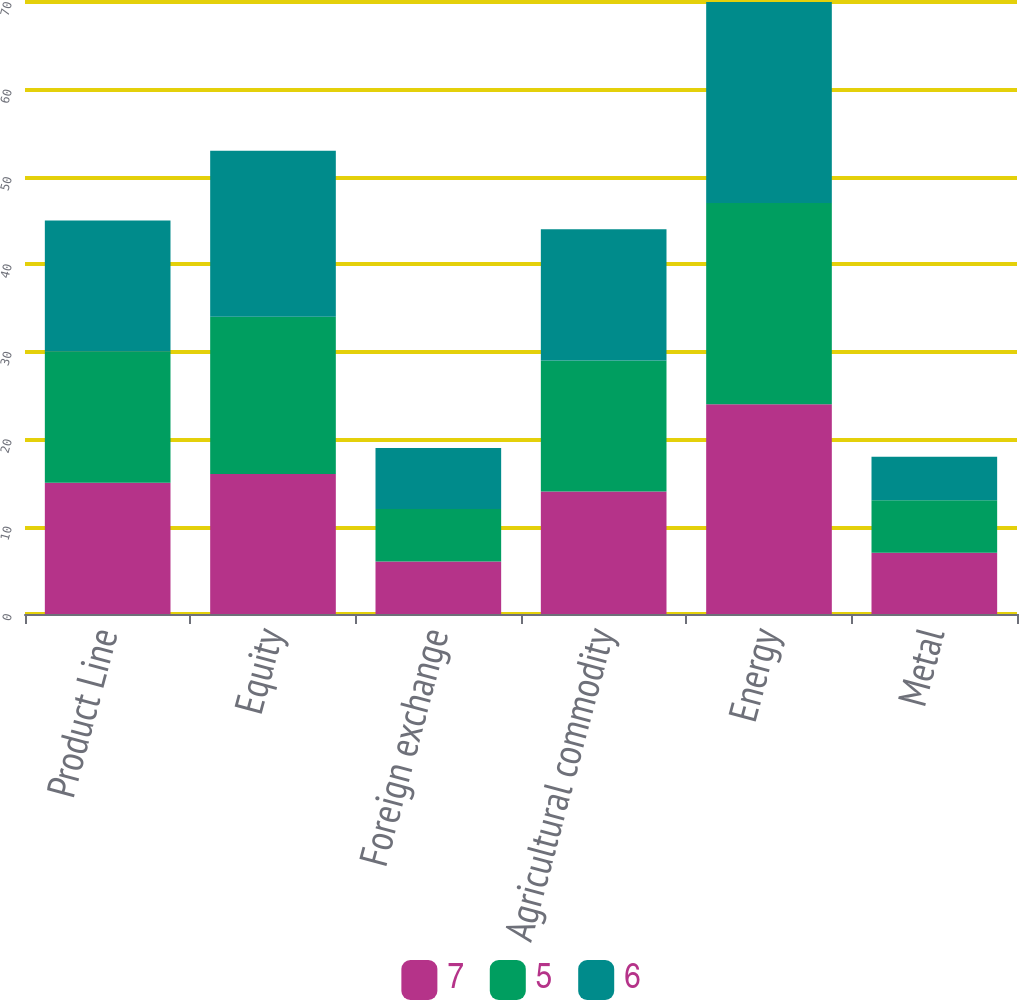Convert chart to OTSL. <chart><loc_0><loc_0><loc_500><loc_500><stacked_bar_chart><ecel><fcel>Product Line<fcel>Equity<fcel>Foreign exchange<fcel>Agricultural commodity<fcel>Energy<fcel>Metal<nl><fcel>7<fcel>15<fcel>16<fcel>6<fcel>14<fcel>24<fcel>7<nl><fcel>5<fcel>15<fcel>18<fcel>6<fcel>15<fcel>23<fcel>6<nl><fcel>6<fcel>15<fcel>19<fcel>7<fcel>15<fcel>23<fcel>5<nl></chart> 